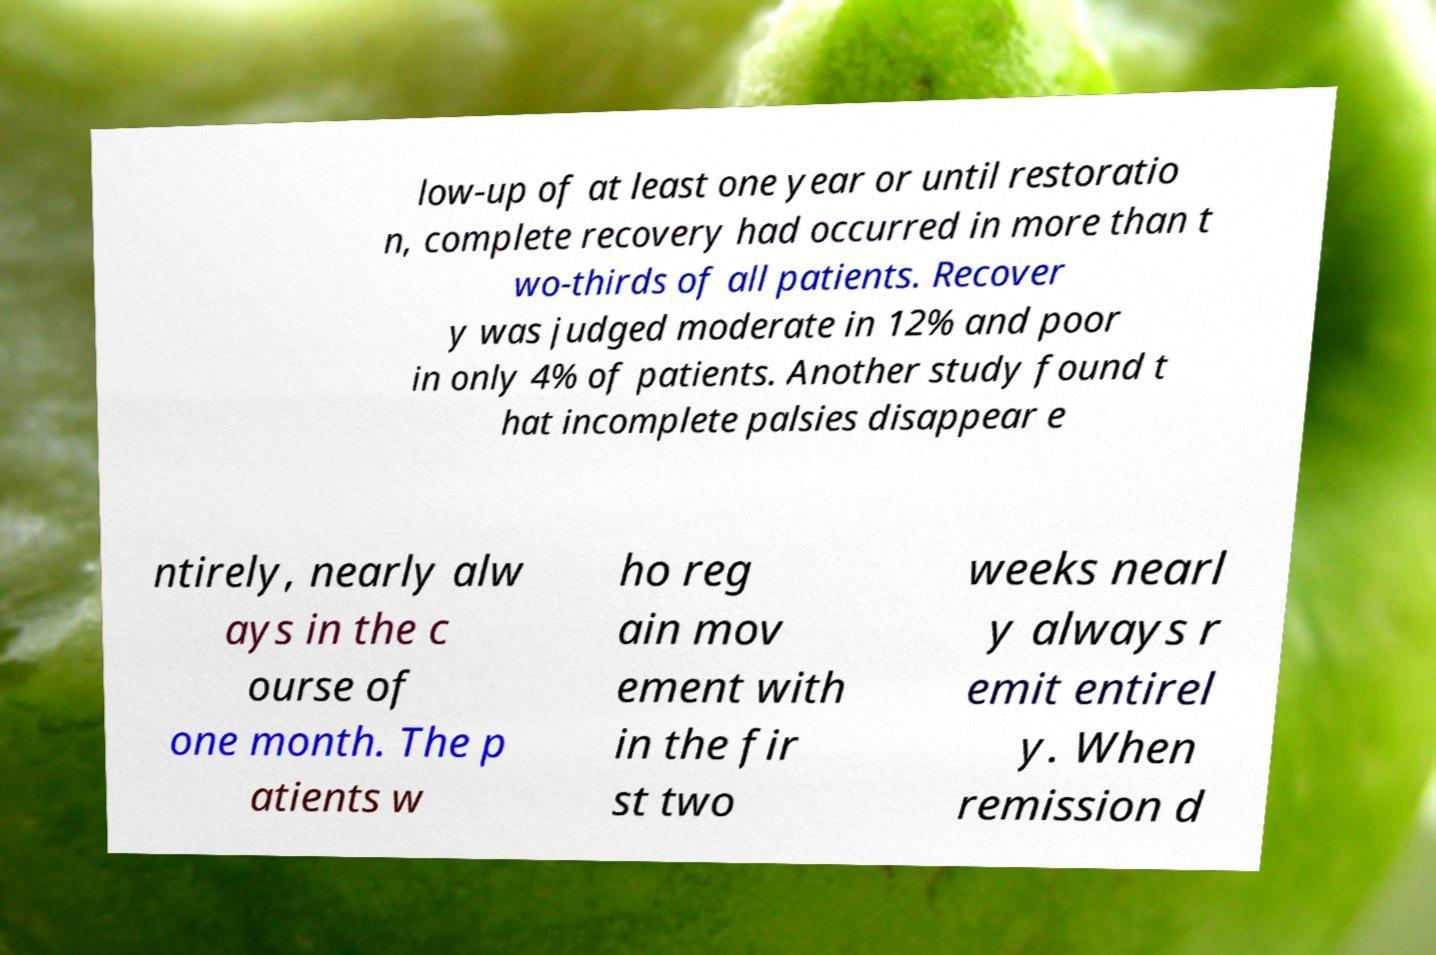Can you read and provide the text displayed in the image?This photo seems to have some interesting text. Can you extract and type it out for me? low-up of at least one year or until restoratio n, complete recovery had occurred in more than t wo-thirds of all patients. Recover y was judged moderate in 12% and poor in only 4% of patients. Another study found t hat incomplete palsies disappear e ntirely, nearly alw ays in the c ourse of one month. The p atients w ho reg ain mov ement with in the fir st two weeks nearl y always r emit entirel y. When remission d 